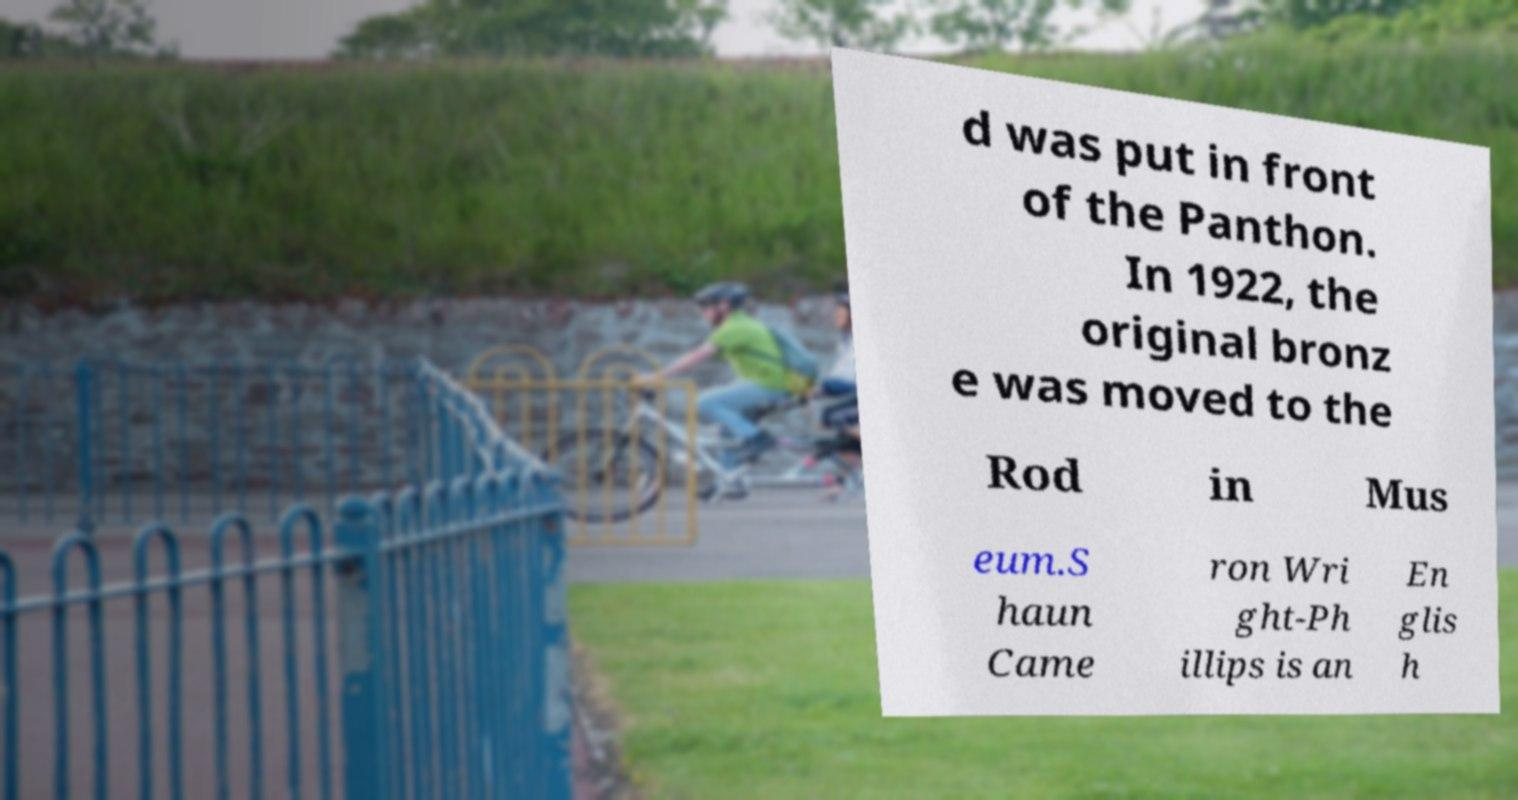Please read and relay the text visible in this image. What does it say? d was put in front of the Panthon. In 1922, the original bronz e was moved to the Rod in Mus eum.S haun Came ron Wri ght-Ph illips is an En glis h 